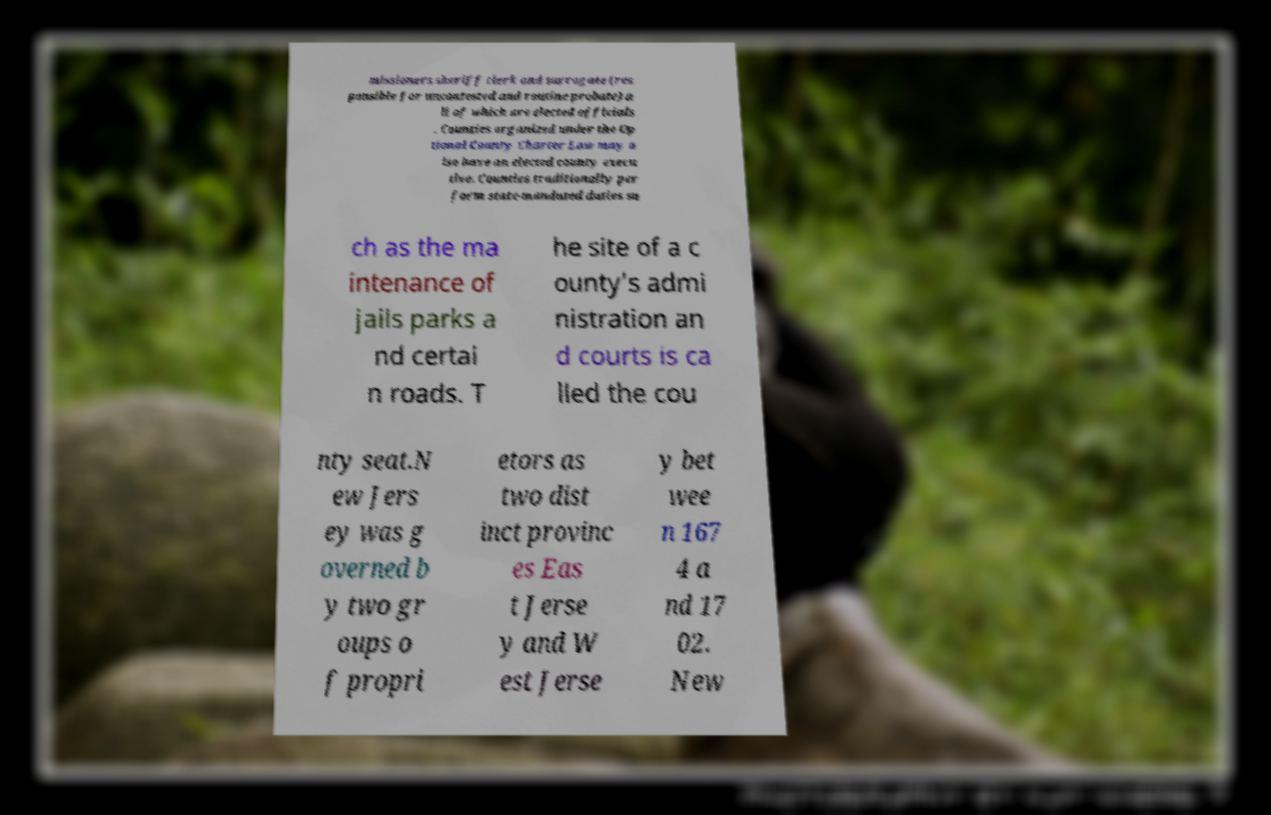Please identify and transcribe the text found in this image. missioners sheriff clerk and surrogate (res ponsible for uncontested and routine probate) a ll of which are elected officials . Counties organized under the Op tional County Charter Law may a lso have an elected county execu tive. Counties traditionally per form state-mandated duties su ch as the ma intenance of jails parks a nd certai n roads. T he site of a c ounty's admi nistration an d courts is ca lled the cou nty seat.N ew Jers ey was g overned b y two gr oups o f propri etors as two dist inct provinc es Eas t Jerse y and W est Jerse y bet wee n 167 4 a nd 17 02. New 